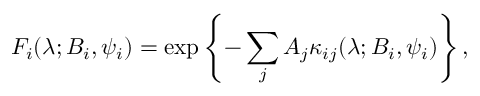Convert formula to latex. <formula><loc_0><loc_0><loc_500><loc_500>F _ { i } ( \lambda ; B _ { i } , \psi _ { i } ) = \exp \left \{ - \sum _ { j } A _ { j } \kappa _ { i j } ( \lambda ; B _ { i } , \psi _ { i } ) \right \} ,</formula> 